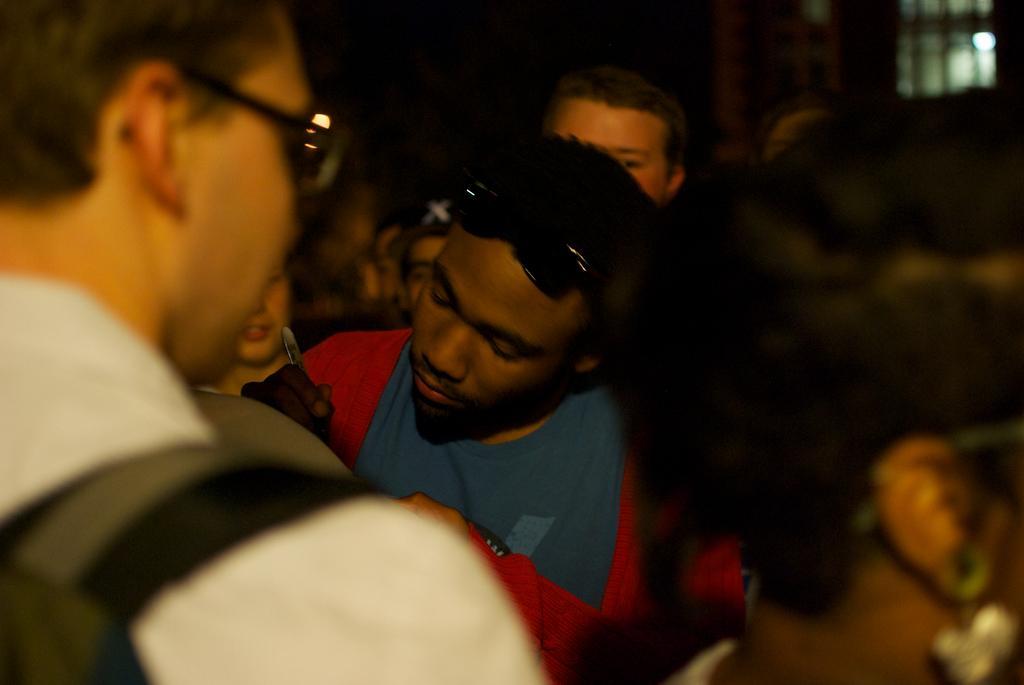Describe this image in one or two sentences. In this image I can see the group of people. In front the person is wearing green color shirt and I can see the dark background. 